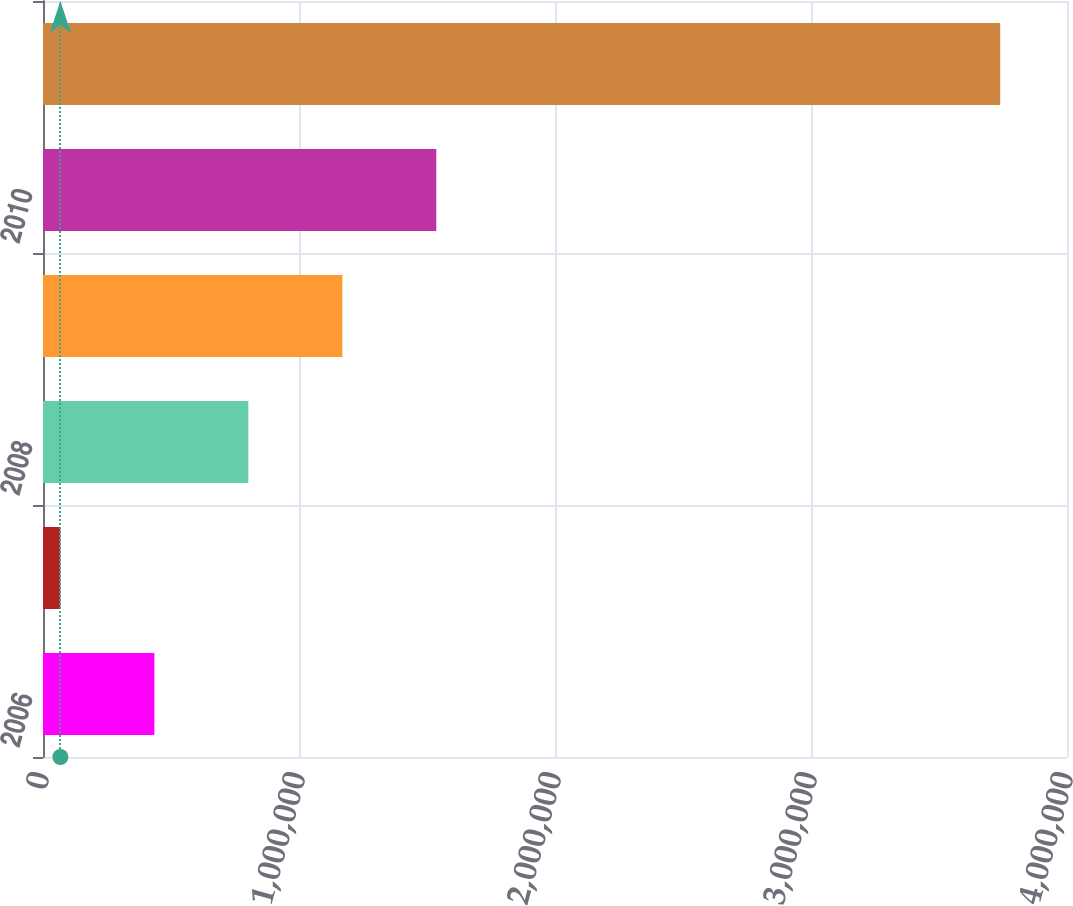<chart> <loc_0><loc_0><loc_500><loc_500><bar_chart><fcel>2006<fcel>2007<fcel>2008<fcel>2009<fcel>2010<fcel>Thereafter<nl><fcel>435008<fcel>67886<fcel>802130<fcel>1.16925e+06<fcel>1.53637e+06<fcel>3.7391e+06<nl></chart> 